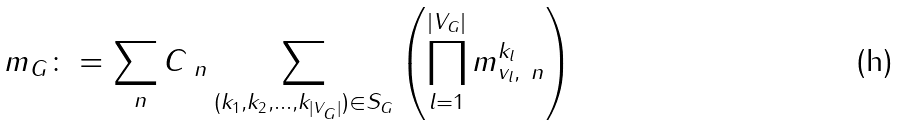Convert formula to latex. <formula><loc_0><loc_0><loc_500><loc_500>m _ { G } \colon = \sum _ { \ n } C _ { \ n } \sum _ { ( k _ { 1 } , k _ { 2 } , \dots , k _ { | V _ { G } | } ) \in S _ { G } } \left ( \prod _ { l = 1 } ^ { | V _ { G } | } m ^ { k _ { l } } _ { v _ { l } , \ n } \right )</formula> 